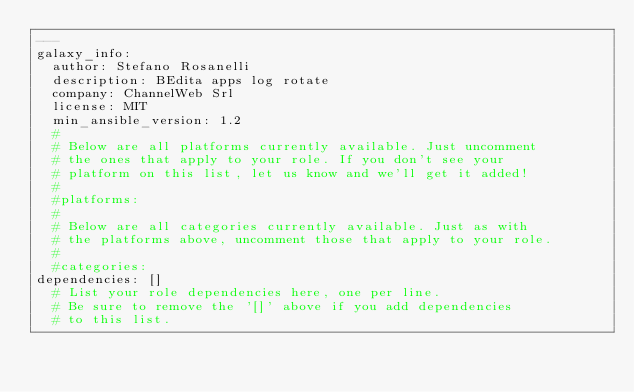Convert code to text. <code><loc_0><loc_0><loc_500><loc_500><_YAML_>---
galaxy_info:
  author: Stefano Rosanelli
  description: BEdita apps log rotate
  company: ChannelWeb Srl
  license: MIT
  min_ansible_version: 1.2
  #
  # Below are all platforms currently available. Just uncomment
  # the ones that apply to your role. If you don't see your 
  # platform on this list, let us know and we'll get it added!
  #
  #platforms:
  #
  # Below are all categories currently available. Just as with
  # the platforms above, uncomment those that apply to your role.
  #
  #categories:
dependencies: []
  # List your role dependencies here, one per line.
  # Be sure to remove the '[]' above if you add dependencies
  # to this list.
  
</code> 